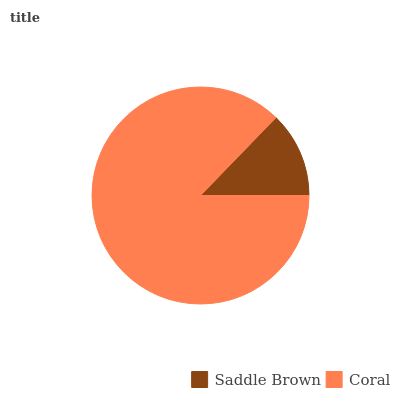Is Saddle Brown the minimum?
Answer yes or no. Yes. Is Coral the maximum?
Answer yes or no. Yes. Is Coral the minimum?
Answer yes or no. No. Is Coral greater than Saddle Brown?
Answer yes or no. Yes. Is Saddle Brown less than Coral?
Answer yes or no. Yes. Is Saddle Brown greater than Coral?
Answer yes or no. No. Is Coral less than Saddle Brown?
Answer yes or no. No. Is Coral the high median?
Answer yes or no. Yes. Is Saddle Brown the low median?
Answer yes or no. Yes. Is Saddle Brown the high median?
Answer yes or no. No. Is Coral the low median?
Answer yes or no. No. 